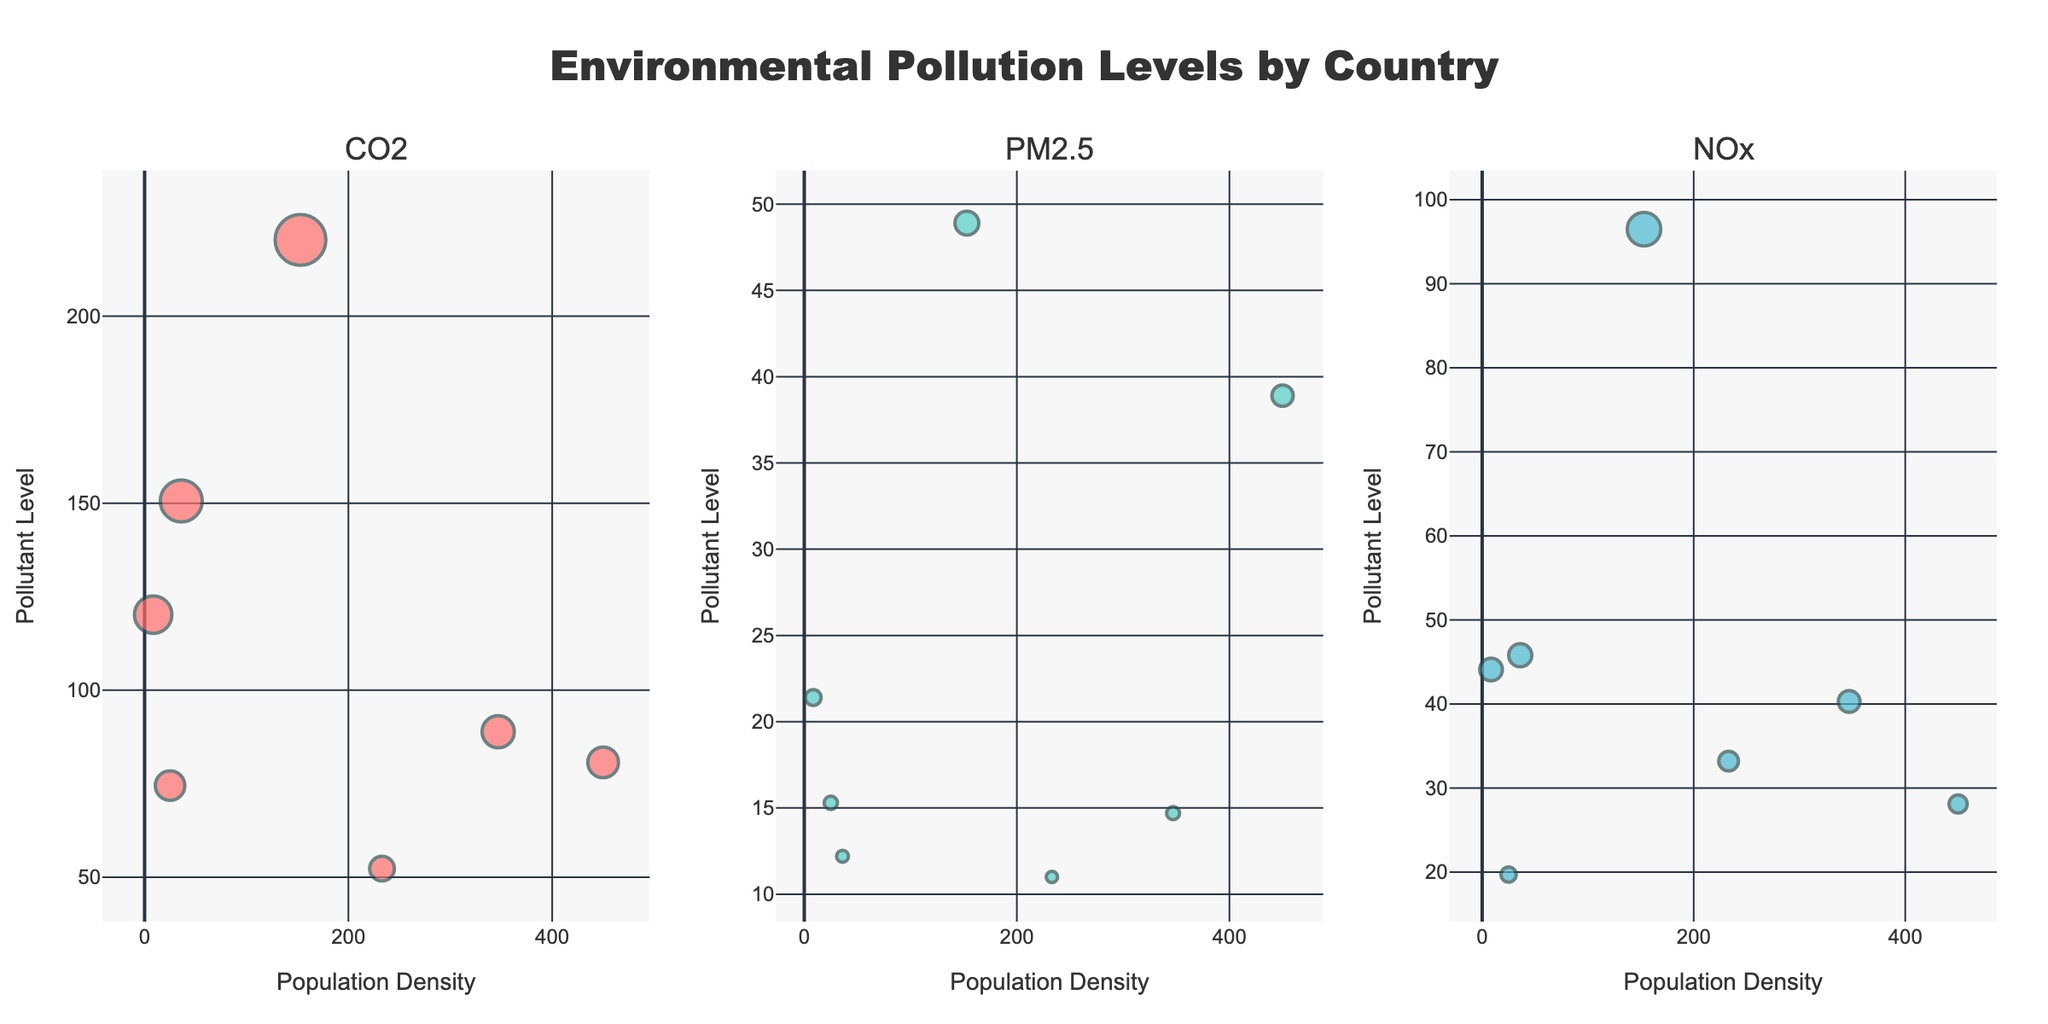What is the title of the plot? The title of the plot is displayed at the top center of the figure. It reads "Environmental Pollution Levels by Country."
Answer: Environmental Pollution Levels by Country How many countries have CO2 levels shown in the figure? Refer to the subplot titled "CO2." Each marker represents a country. Count the markers to determine the number of countries.
Answer: 6 Which country has the highest PM2.5 level? Look at the PM2.5 subplot and identify the marker positioned at the highest point along the y-axis. The hover text will reveal the country name.
Answer: China What is the population density and pollutant level of Brazil for NOx? Refer to the NOx subplot and find the marker for Brazil. The hover text will display both the population density and pollutant level.
Answer: Population Density: 25, Pollutant Level: 19.7 Which pollutant has the largest bubble size overall? The bubble size corresponds to the pollutant level. Compare the size of the largest bubbles across all three subplots (CO2, PM2.5, NOx) to determine which pollutant has the largest bubble.
Answer: CO2 Among the three pollutants, which country appears in the same position on the x-axis but varies significantly on the y-axis? Inspect the subplots to identify a country with a consistent population density value (x-axis) but varying pollutant levels (y-axis).
Answer: United States Which country has the highest population density among those plotted in the NOx subplot? In the NOx subplot, find the marker farthest to the right (highest x-axis value). The hover text will reveal the country name.
Answer: India What is the average pollutant level for Germany across the three pollutants? Extract the pollutant levels for Germany from each subplot (CO2, PM2.5, NOx) and compute the average. (52.3 + 11.0 + 33.2)/3 = 32.17
Answer: 32.17 What is the difference in pollutant level of NOx between Japan and India? Refer to the NOx subplot and note the pollutant levels for Japan and India. Subtract India's level from Japan's level. 40.3 - 28.1 = 12.2
Answer: 12.2 Which pollutant has the most variation in level among all countries? Observe the spread of markers along the y-axis (pollutant level) in each subplot. The subplot with the widest spread indicates the most variation.
Answer: NOx 